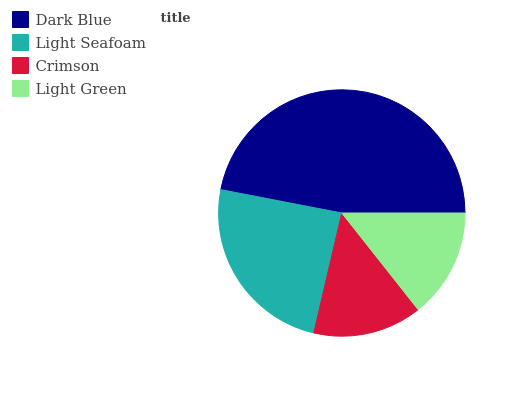Is Crimson the minimum?
Answer yes or no. Yes. Is Dark Blue the maximum?
Answer yes or no. Yes. Is Light Seafoam the minimum?
Answer yes or no. No. Is Light Seafoam the maximum?
Answer yes or no. No. Is Dark Blue greater than Light Seafoam?
Answer yes or no. Yes. Is Light Seafoam less than Dark Blue?
Answer yes or no. Yes. Is Light Seafoam greater than Dark Blue?
Answer yes or no. No. Is Dark Blue less than Light Seafoam?
Answer yes or no. No. Is Light Seafoam the high median?
Answer yes or no. Yes. Is Light Green the low median?
Answer yes or no. Yes. Is Light Green the high median?
Answer yes or no. No. Is Dark Blue the low median?
Answer yes or no. No. 